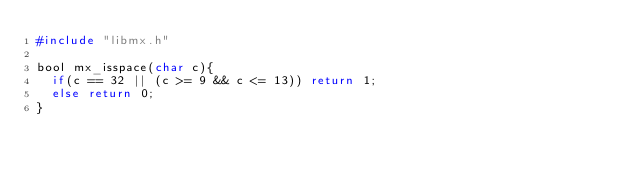<code> <loc_0><loc_0><loc_500><loc_500><_C_>#include "libmx.h"

bool mx_isspace(char c){
	if(c == 32 || (c >= 9 && c <= 13)) return 1;
	else return 0;
}
</code> 